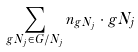<formula> <loc_0><loc_0><loc_500><loc_500>\sum _ { g N _ { j } \in G / N _ { j } } n _ { g N _ { j } } \cdot g N _ { j }</formula> 